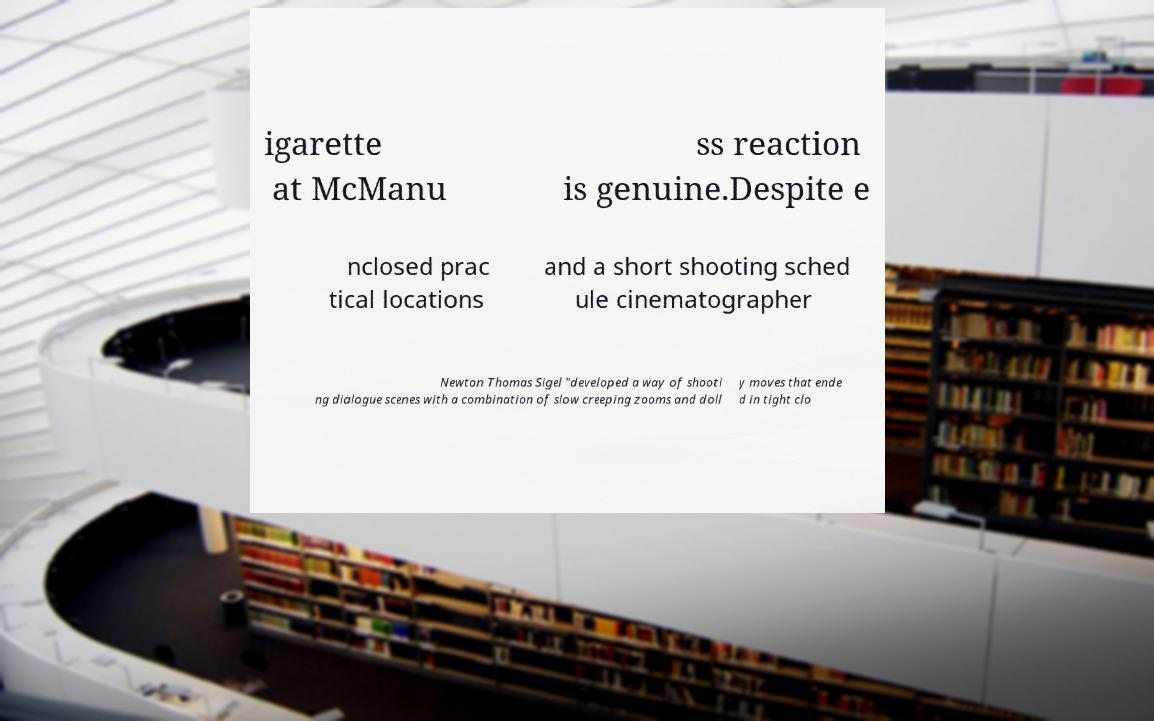Can you accurately transcribe the text from the provided image for me? igarette at McManu ss reaction is genuine.Despite e nclosed prac tical locations and a short shooting sched ule cinematographer Newton Thomas Sigel "developed a way of shooti ng dialogue scenes with a combination of slow creeping zooms and doll y moves that ende d in tight clo 